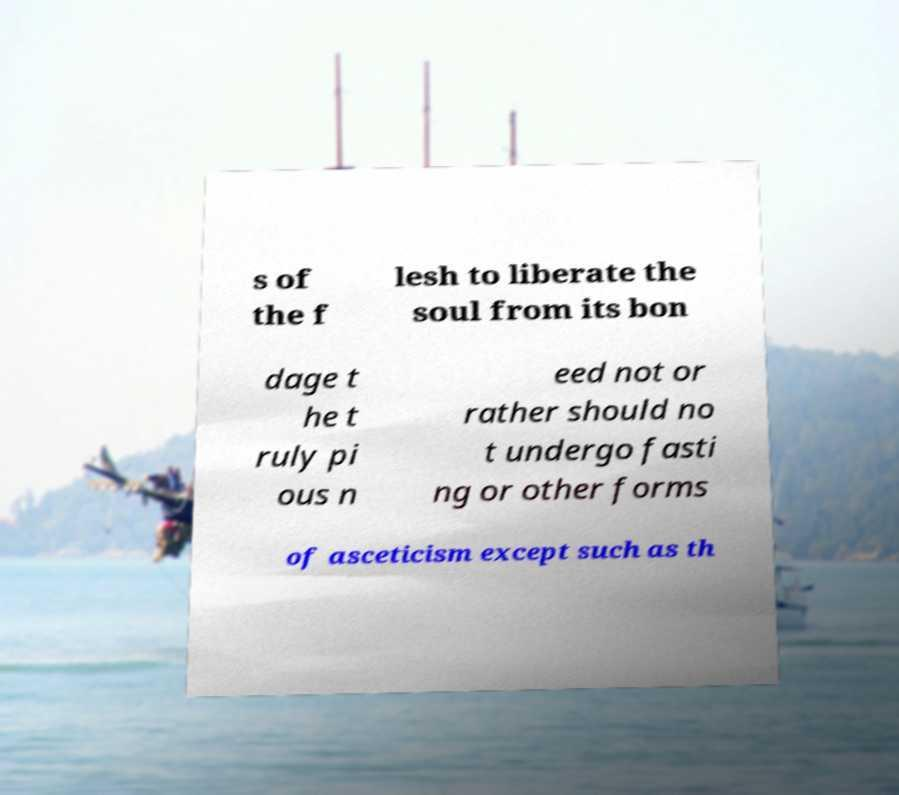What messages or text are displayed in this image? I need them in a readable, typed format. s of the f lesh to liberate the soul from its bon dage t he t ruly pi ous n eed not or rather should no t undergo fasti ng or other forms of asceticism except such as th 